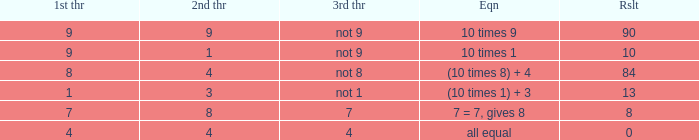What is the equation where the 3rd throw is 7? 7 = 7, gives 8. 